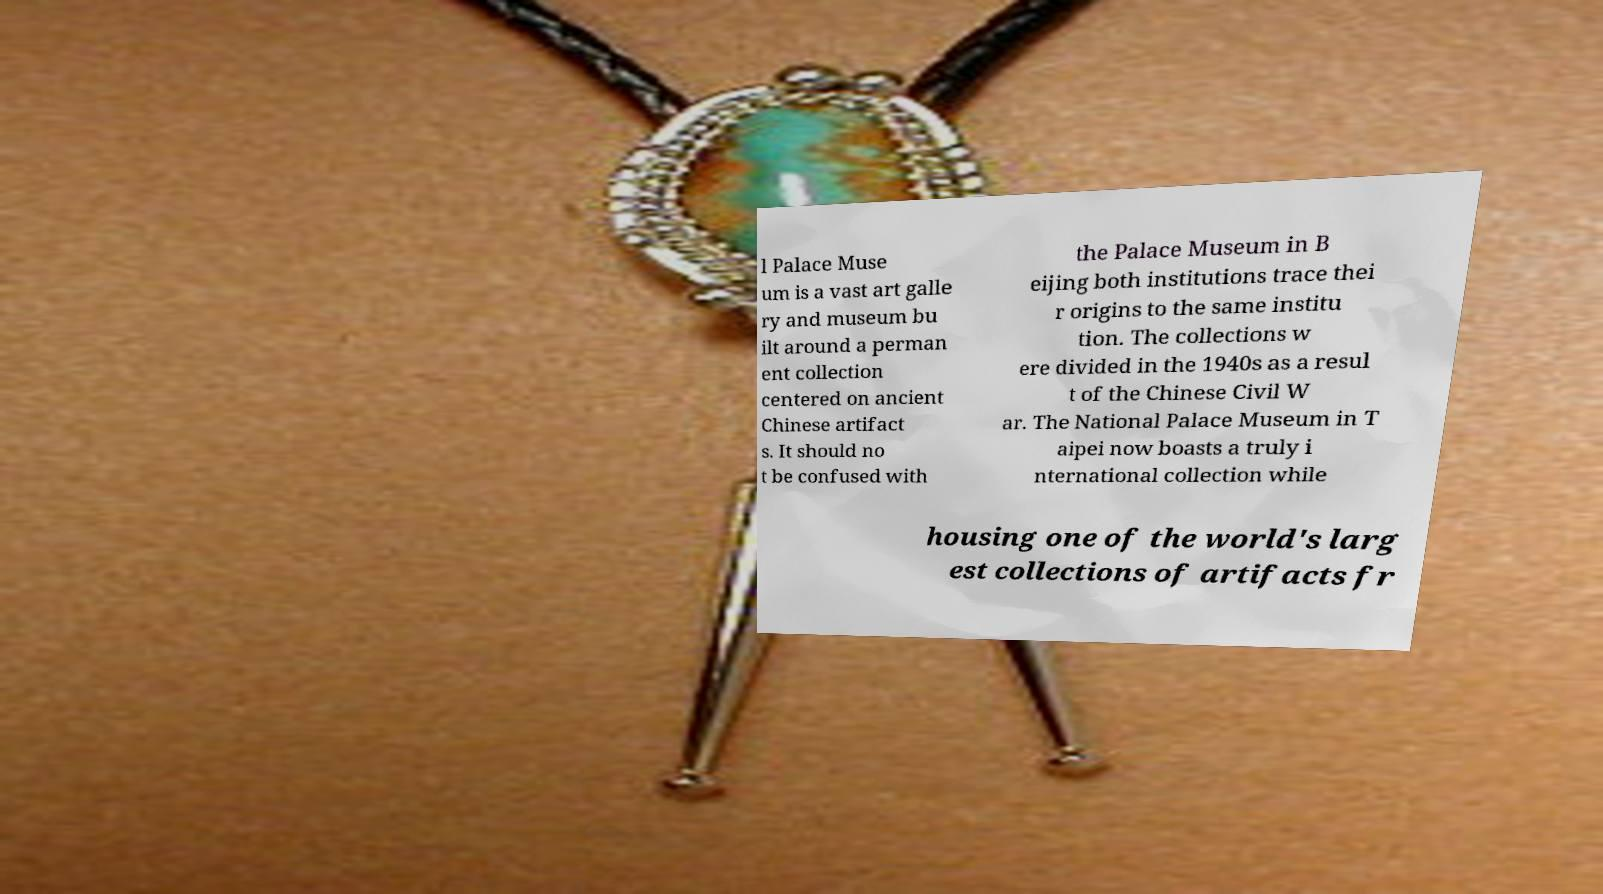Could you assist in decoding the text presented in this image and type it out clearly? l Palace Muse um is a vast art galle ry and museum bu ilt around a perman ent collection centered on ancient Chinese artifact s. It should no t be confused with the Palace Museum in B eijing both institutions trace thei r origins to the same institu tion. The collections w ere divided in the 1940s as a resul t of the Chinese Civil W ar. The National Palace Museum in T aipei now boasts a truly i nternational collection while housing one of the world's larg est collections of artifacts fr 